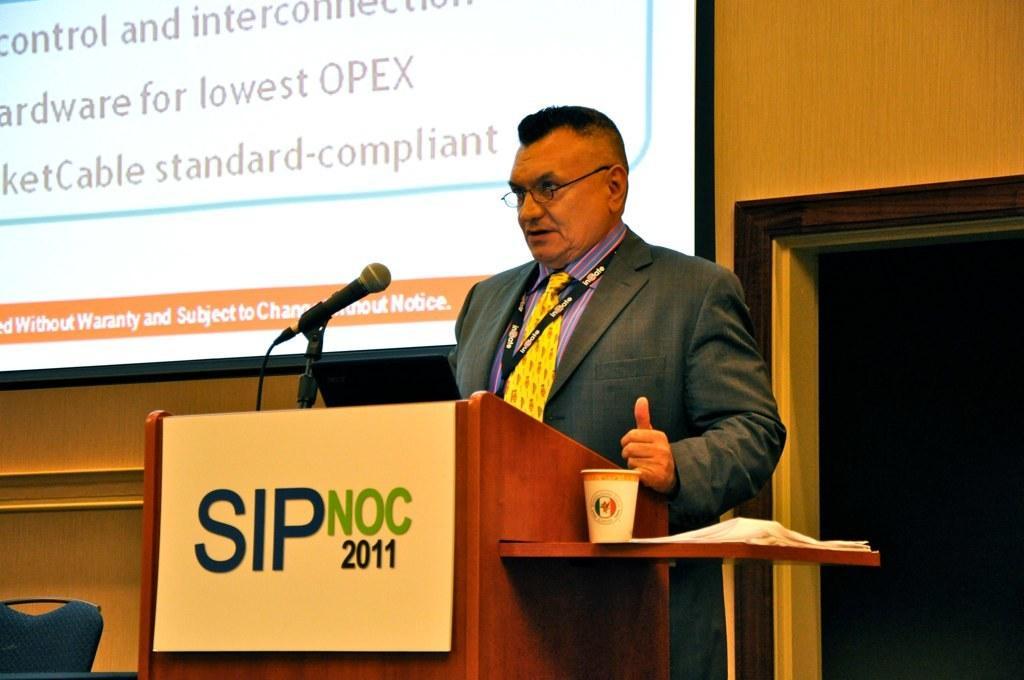Could you give a brief overview of what you see in this image? In this picture we can see a man is standing behind the podium and on the podium there is a microphone with stand and a cable. On the right side of the podium there is a cup and papers on an object and on the left side of the podium there is a chair. Behind the man there is a wooden wall and a projector screen. 